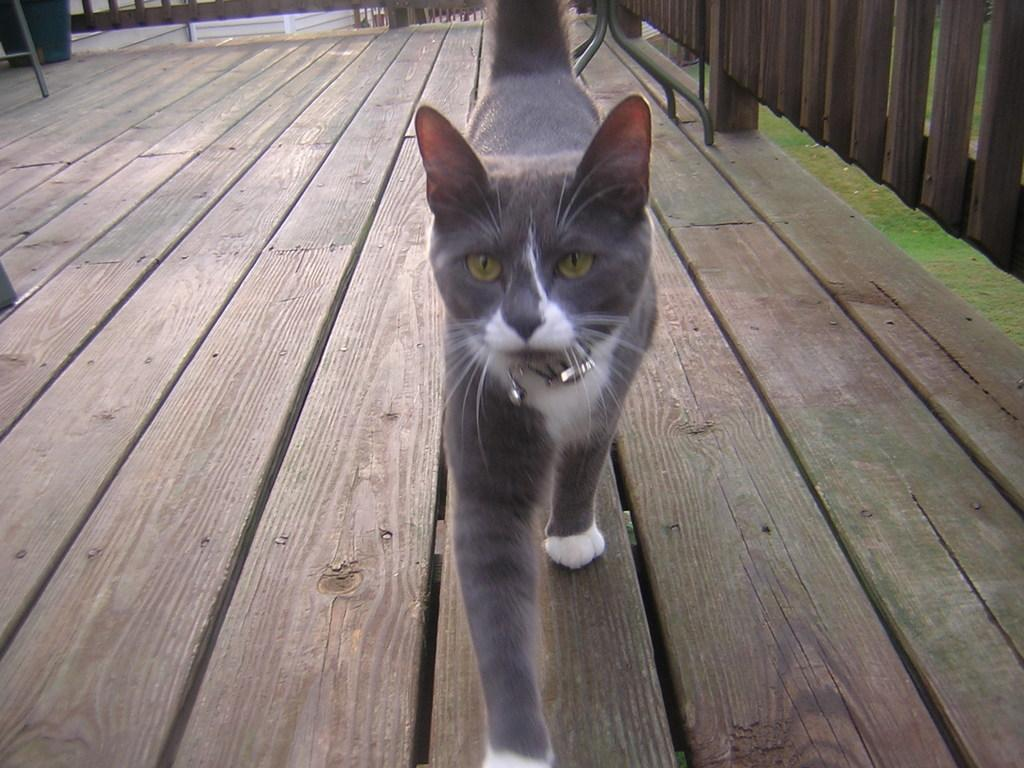What animal can be seen in the image? There is a cat in the image. What is the cat doing in the image? The cat is walking on a wooden path. Can you describe the appearance of the cat? The cat is in ash and white color. What can be seen in the background of the image? There is fencing and green grass visible in the background. What type of flower is the cat holding in its mouth in the image? There is no flower present in the image, and the cat is not holding anything in its mouth. 